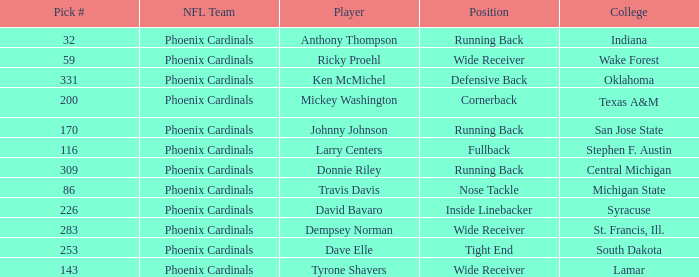Write the full table. {'header': ['Pick #', 'NFL Team', 'Player', 'Position', 'College'], 'rows': [['32', 'Phoenix Cardinals', 'Anthony Thompson', 'Running Back', 'Indiana'], ['59', 'Phoenix Cardinals', 'Ricky Proehl', 'Wide Receiver', 'Wake Forest'], ['331', 'Phoenix Cardinals', 'Ken McMichel', 'Defensive Back', 'Oklahoma'], ['200', 'Phoenix Cardinals', 'Mickey Washington', 'Cornerback', 'Texas A&M'], ['170', 'Phoenix Cardinals', 'Johnny Johnson', 'Running Back', 'San Jose State'], ['116', 'Phoenix Cardinals', 'Larry Centers', 'Fullback', 'Stephen F. Austin'], ['309', 'Phoenix Cardinals', 'Donnie Riley', 'Running Back', 'Central Michigan'], ['86', 'Phoenix Cardinals', 'Travis Davis', 'Nose Tackle', 'Michigan State'], ['226', 'Phoenix Cardinals', 'David Bavaro', 'Inside Linebacker', 'Syracuse'], ['283', 'Phoenix Cardinals', 'Dempsey Norman', 'Wide Receiver', 'St. Francis, Ill.'], ['253', 'Phoenix Cardinals', 'Dave Elle', 'Tight End', 'South Dakota'], ['143', 'Phoenix Cardinals', 'Tyrone Shavers', 'Wide Receiver', 'Lamar']]} Which player was a running back from San Jose State? Johnny Johnson. 